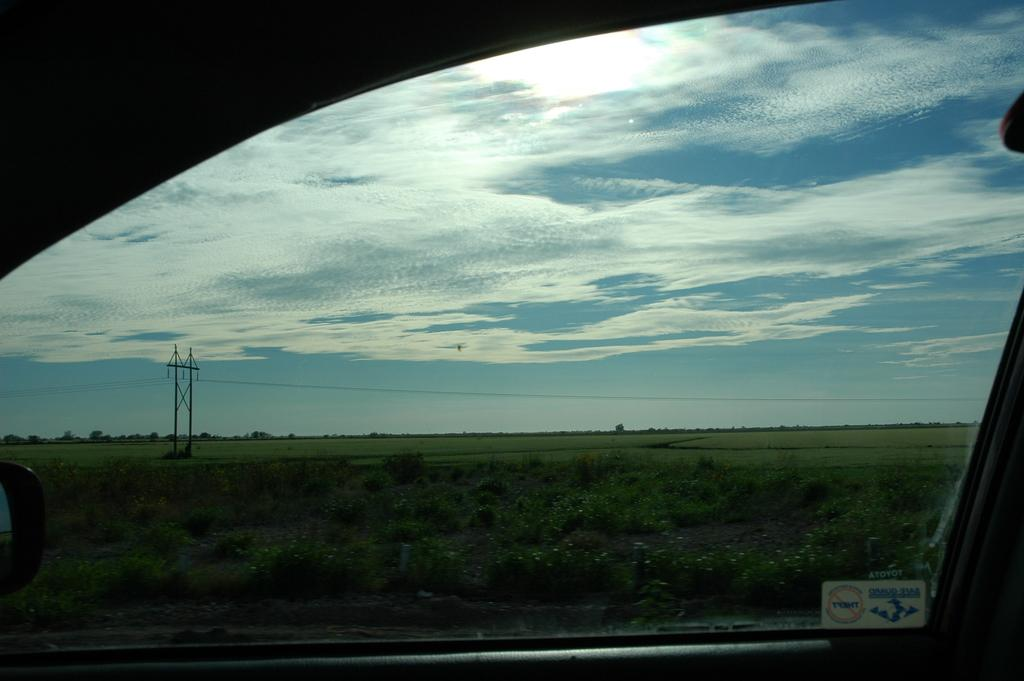What is the main subject of the image? There is a vehicle on the road in the image. What type of natural elements can be seen in the image? There are trees and plants in the image. What type of landscape is visible in the image? There is an agricultural field in the image. What man-made structures are present in the image? There are poles and electric cables in the image. What is visible in the sky in the image? There are clouds in the sky in the image. What letters can be seen on the stove in the image? There is no stove present in the image, so no letters can be seen on it. 